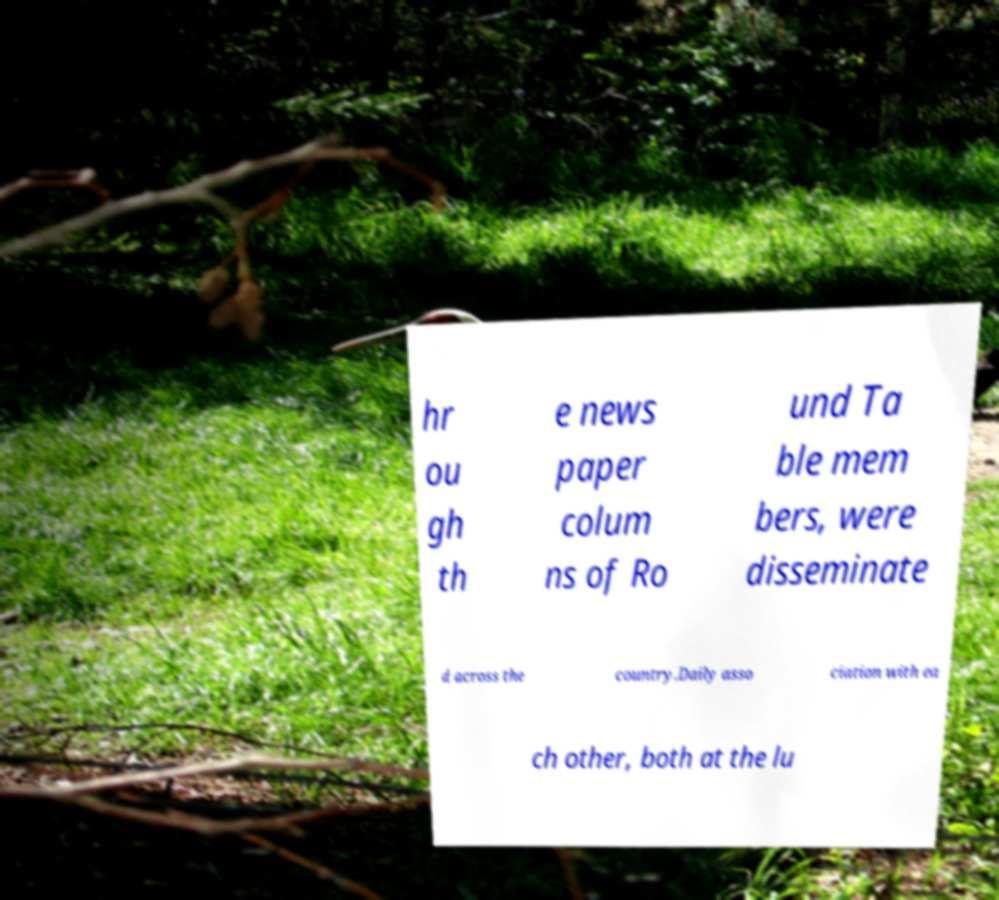Please identify and transcribe the text found in this image. hr ou gh th e news paper colum ns of Ro und Ta ble mem bers, were disseminate d across the country.Daily asso ciation with ea ch other, both at the lu 